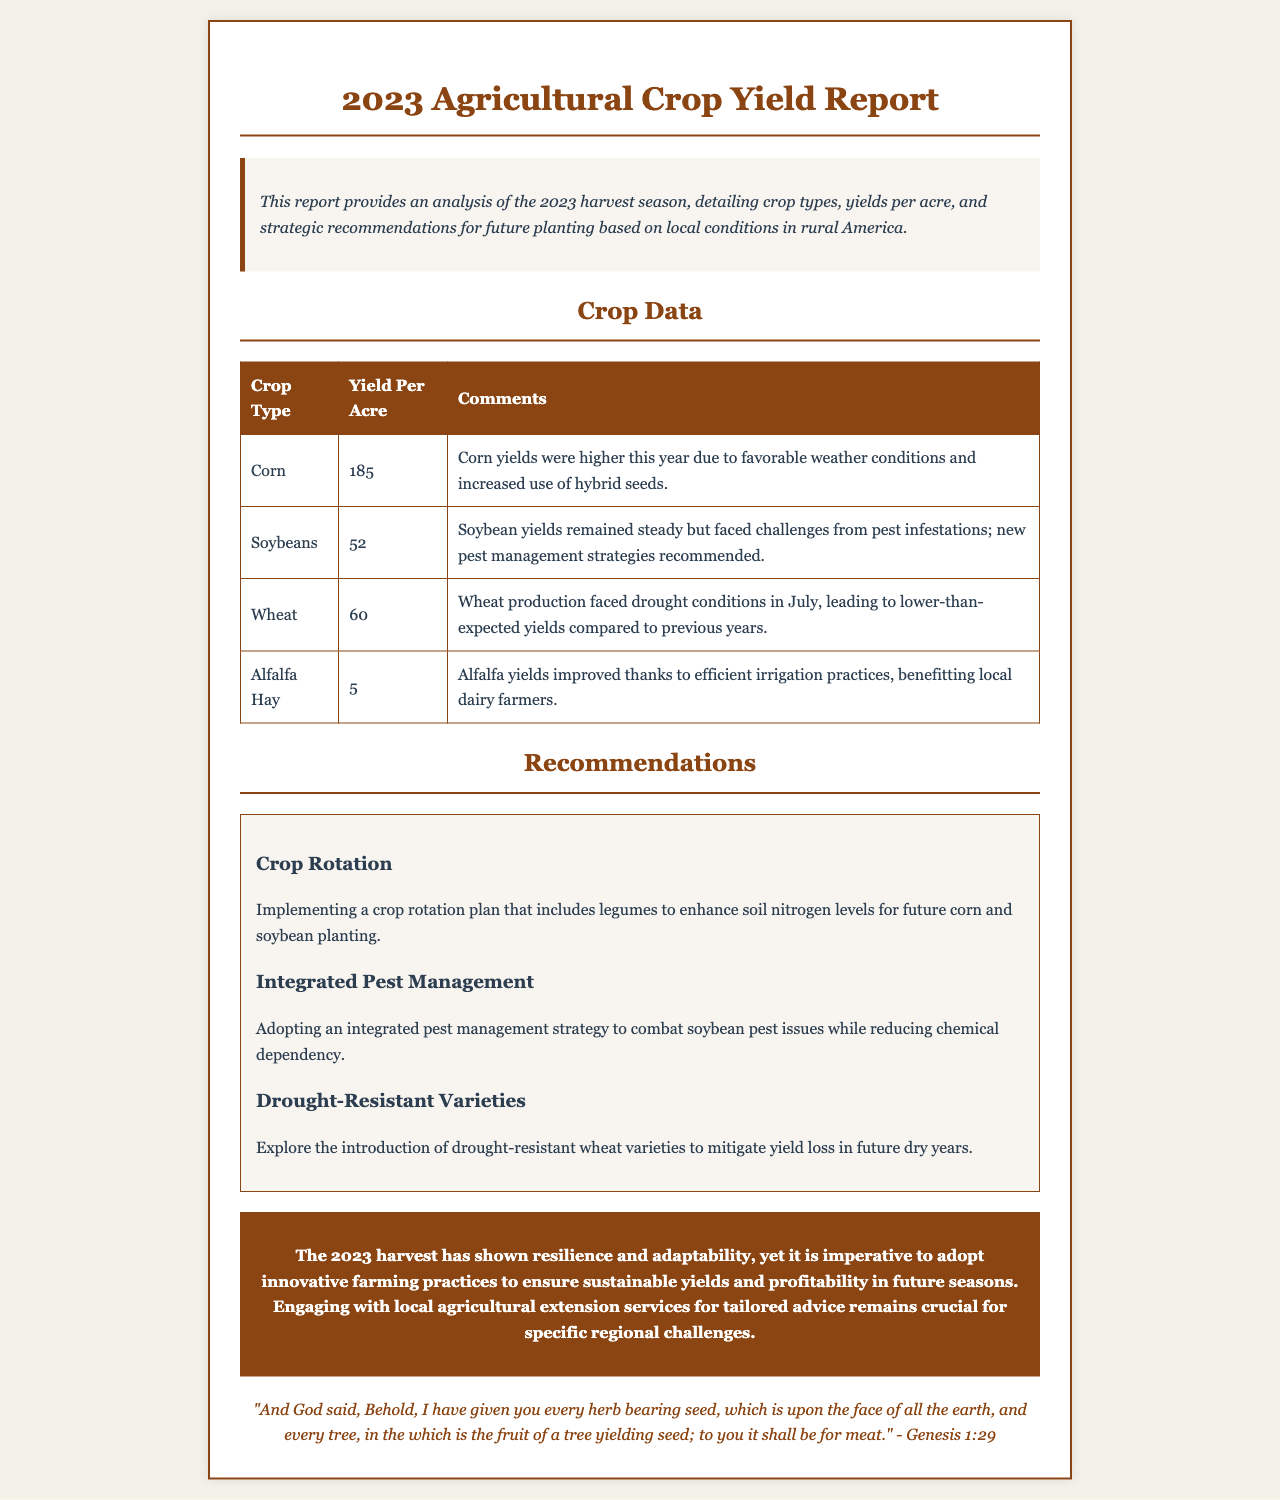What was the yield per acre for corn? The yield per acre for corn is specifically stated in the document as 185.
Answer: 185 What recommendation is made regarding pest management? The report recommends adopting an integrated pest management strategy to combat soybean pest issues.
Answer: Integrated pest management How did wheat production fare during the year? The document notes that wheat production faced drought conditions in July, leading to lower yields.
Answer: Lower yields What crop type had the highest yield per acre? By reviewing the crop data in the report, it can be determined that corn had the highest yield.
Answer: Corn What is one strategy suggested to improve future corn and soybean planting? The report suggests implementing a crop rotation plan that includes legumes to enhance soil nitrogen.
Answer: Crop rotation plan with legumes What is the reported yield per acre for alfalfa hay? The specific yield per acre for alfalfa hay is provided as 5.
Answer: 5 Which crop faced challenges from pest infestations? The document mentions that soybeans faced challenges from pest infestations.
Answer: Soybeans According to the report, what verse is cited at the end? The ending of the report references a verse from Genesis 1:29.
Answer: Genesis 1:29 What was the primary weather condition impacting wheat yields? Drought conditions in July are highlighted as the primary impact on wheat yields.
Answer: Drought conditions 